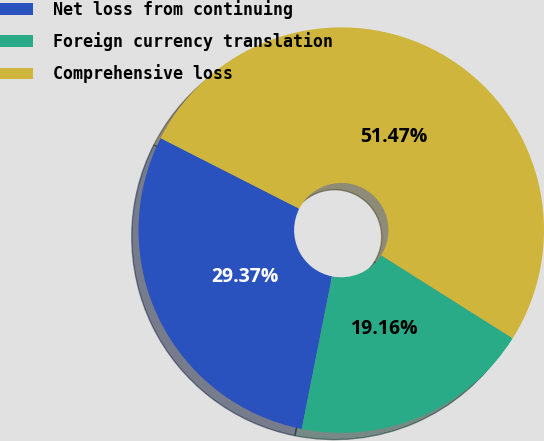Convert chart. <chart><loc_0><loc_0><loc_500><loc_500><pie_chart><fcel>Net loss from continuing<fcel>Foreign currency translation<fcel>Comprehensive loss<nl><fcel>29.37%<fcel>19.16%<fcel>51.47%<nl></chart> 